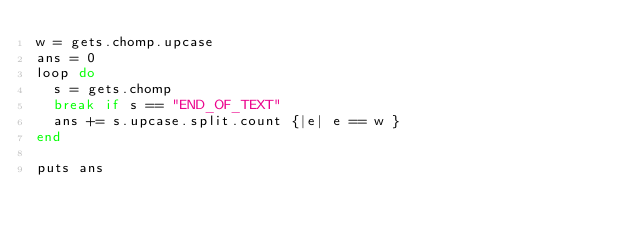<code> <loc_0><loc_0><loc_500><loc_500><_Ruby_>w = gets.chomp.upcase
ans = 0
loop do
  s = gets.chomp
  break if s == "END_OF_TEXT"
  ans += s.upcase.split.count {|e| e == w }
end

puts ans</code> 